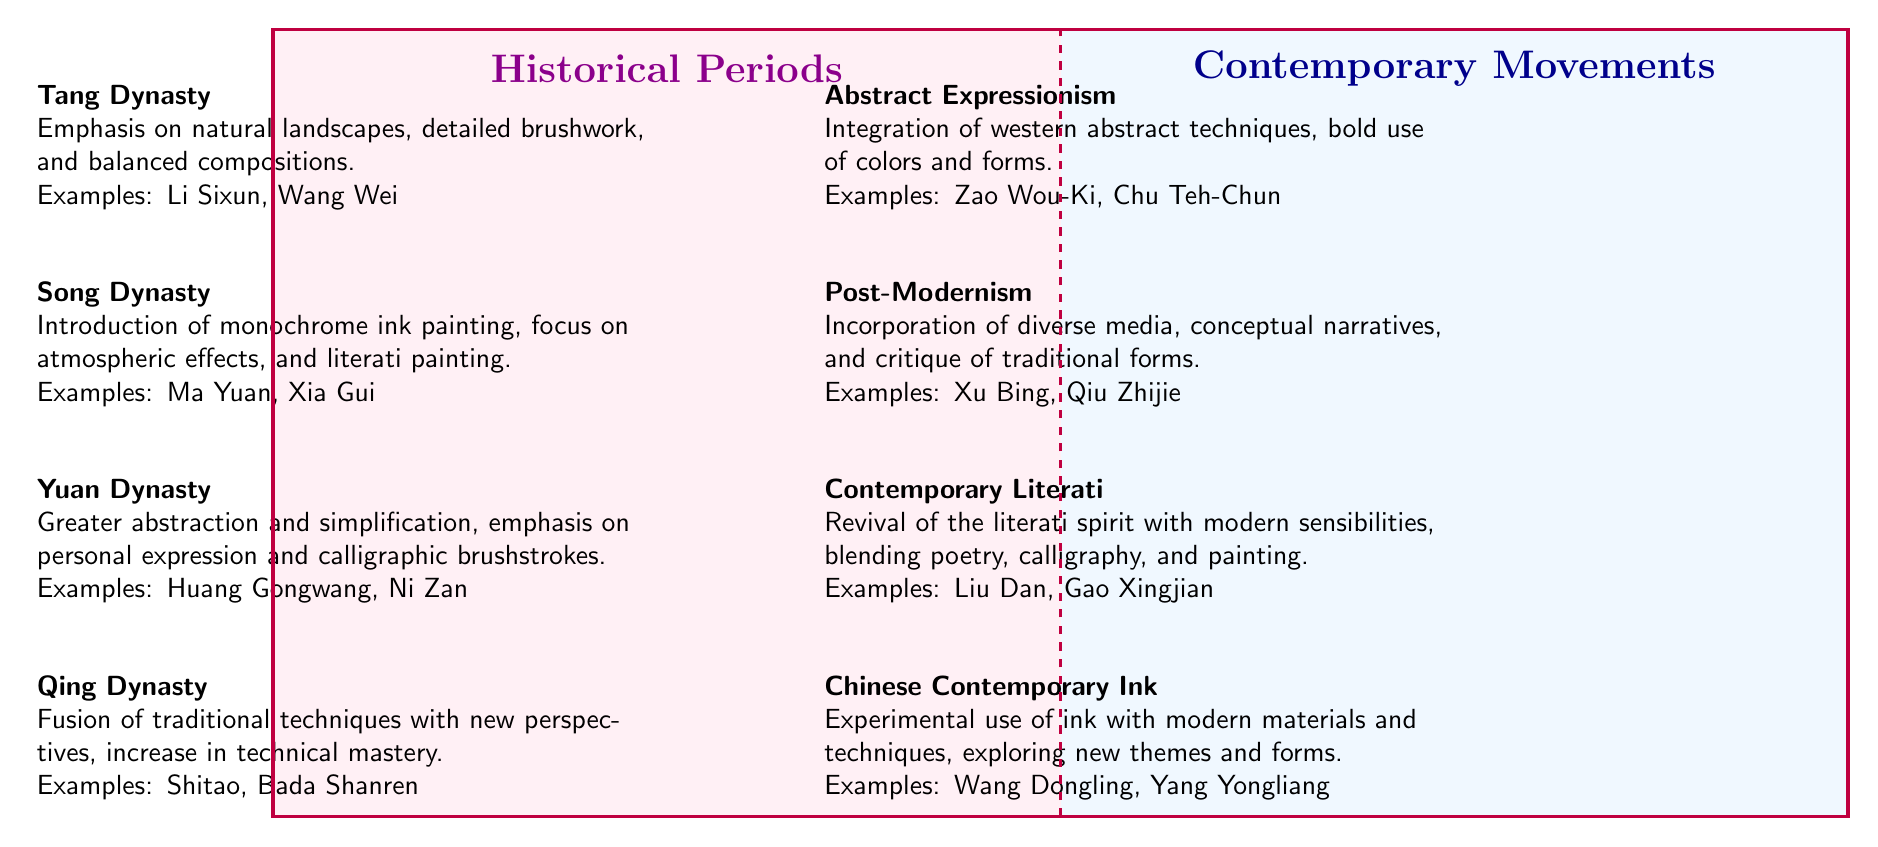What is the main influence of the Song Dynasty? The Song Dynasty emphasizes monochrome ink painting, atmospheric effects, and literati painting. This information can be directly found in the respective quadrant's description of the Song Dynasty.
Answer: Monochrome ink painting Who are the examples of the Yuan Dynasty? The examples provided for the Yuan Dynasty are Huang Gongwang and Ni Zan. This information can be traced in the list of elements under the Yuan Dynasty in the diagram.
Answer: Huang Gongwang, Ni Zan How many elements are listed under Historical Periods? The Historical Periods section consists of four elements: Tang Dynasty, Song Dynasty, Yuan Dynasty, and Qing Dynasty, which can be counted directly from the respective list in the diagram.
Answer: 4 What is the influence of Chinese Contemporary Ink? The Chinese Contemporary Ink emphasizes experimental use of ink with modern materials and techniques, as stated in the description of the element. This can be directly referenced in the diagram.
Answer: Experimental use of ink Which contemporary movement incorporates western abstract techniques? The Abstract Expressionism movement is characterized by the integration of western abstract techniques, bold use of colors, and forms, which is clearly indicated in the quadrant for Contemporary Movements.
Answer: Abstract Expressionism What two dynasties emphasize natural landscapes? The Tang Dynasty and the Qing Dynasty emphasize natural landscapes within their influences as discussed in their respective sections. This requires connecting the influences from the descriptions of both dynasties in the Historical Periods quadrant.
Answer: Tang Dynasty, Qing Dynasty Which type of movement revives the literati spirit? The Contemporary Literati movement is specifically noted for reviving the literati spirit with modern sensibilities, as mentioned in its description within the Contemporary Movements quadrant.
Answer: Contemporary Literati Identify the relationship between the Yuan and Abstract Expressionism. Though they belong to different quadrants, the Yuan Dynasty's emphasis on personal expression and abstraction can be conceptually linked to the bold use of abstract techniques in Abstract Expressionism, highlighting a lineage of evolving artistic expressions. This requires comprehension of both their descriptions and influences across different periods.
Answer: Evolving artistic expressions How are Shitao and Bada Shanren categorized? Shitao and Bada Shanren are categorized as examples under the Qing Dynasty, which can be confirmed by reviewing the examples listed for that element in the Historical Periods quadrant.
Answer: Qing Dynasty 